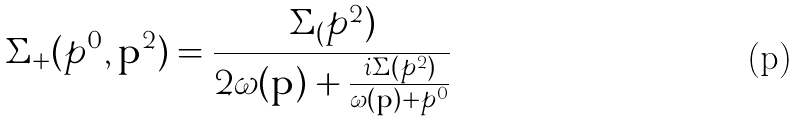Convert formula to latex. <formula><loc_0><loc_0><loc_500><loc_500>\Sigma _ { + } ( p ^ { 0 } , \mathbf p ^ { 2 } ) = \frac { \Sigma _ { ( } p ^ { 2 } ) } { 2 \omega ( \mathbf p ) + \frac { i \Sigma ( p ^ { 2 } ) } { \omega ( \mathbf p ) + p ^ { 0 } } }</formula> 